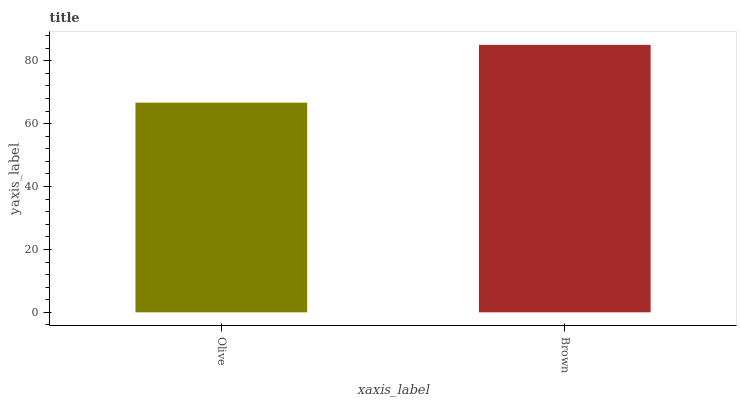Is Olive the minimum?
Answer yes or no. Yes. Is Brown the maximum?
Answer yes or no. Yes. Is Brown the minimum?
Answer yes or no. No. Is Brown greater than Olive?
Answer yes or no. Yes. Is Olive less than Brown?
Answer yes or no. Yes. Is Olive greater than Brown?
Answer yes or no. No. Is Brown less than Olive?
Answer yes or no. No. Is Brown the high median?
Answer yes or no. Yes. Is Olive the low median?
Answer yes or no. Yes. Is Olive the high median?
Answer yes or no. No. Is Brown the low median?
Answer yes or no. No. 